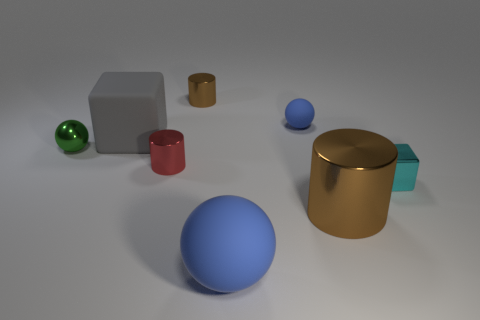Add 1 large blue matte objects. How many objects exist? 9 Subtract all big spheres. How many spheres are left? 2 Subtract all green balls. How many balls are left? 2 Subtract all spheres. How many objects are left? 5 Add 6 large gray matte objects. How many large gray matte objects are left? 7 Add 4 big brown metal objects. How many big brown metal objects exist? 5 Subtract 0 green cylinders. How many objects are left? 8 Subtract 1 blocks. How many blocks are left? 1 Subtract all cyan cylinders. Subtract all cyan balls. How many cylinders are left? 3 Subtract all brown cylinders. How many brown balls are left? 0 